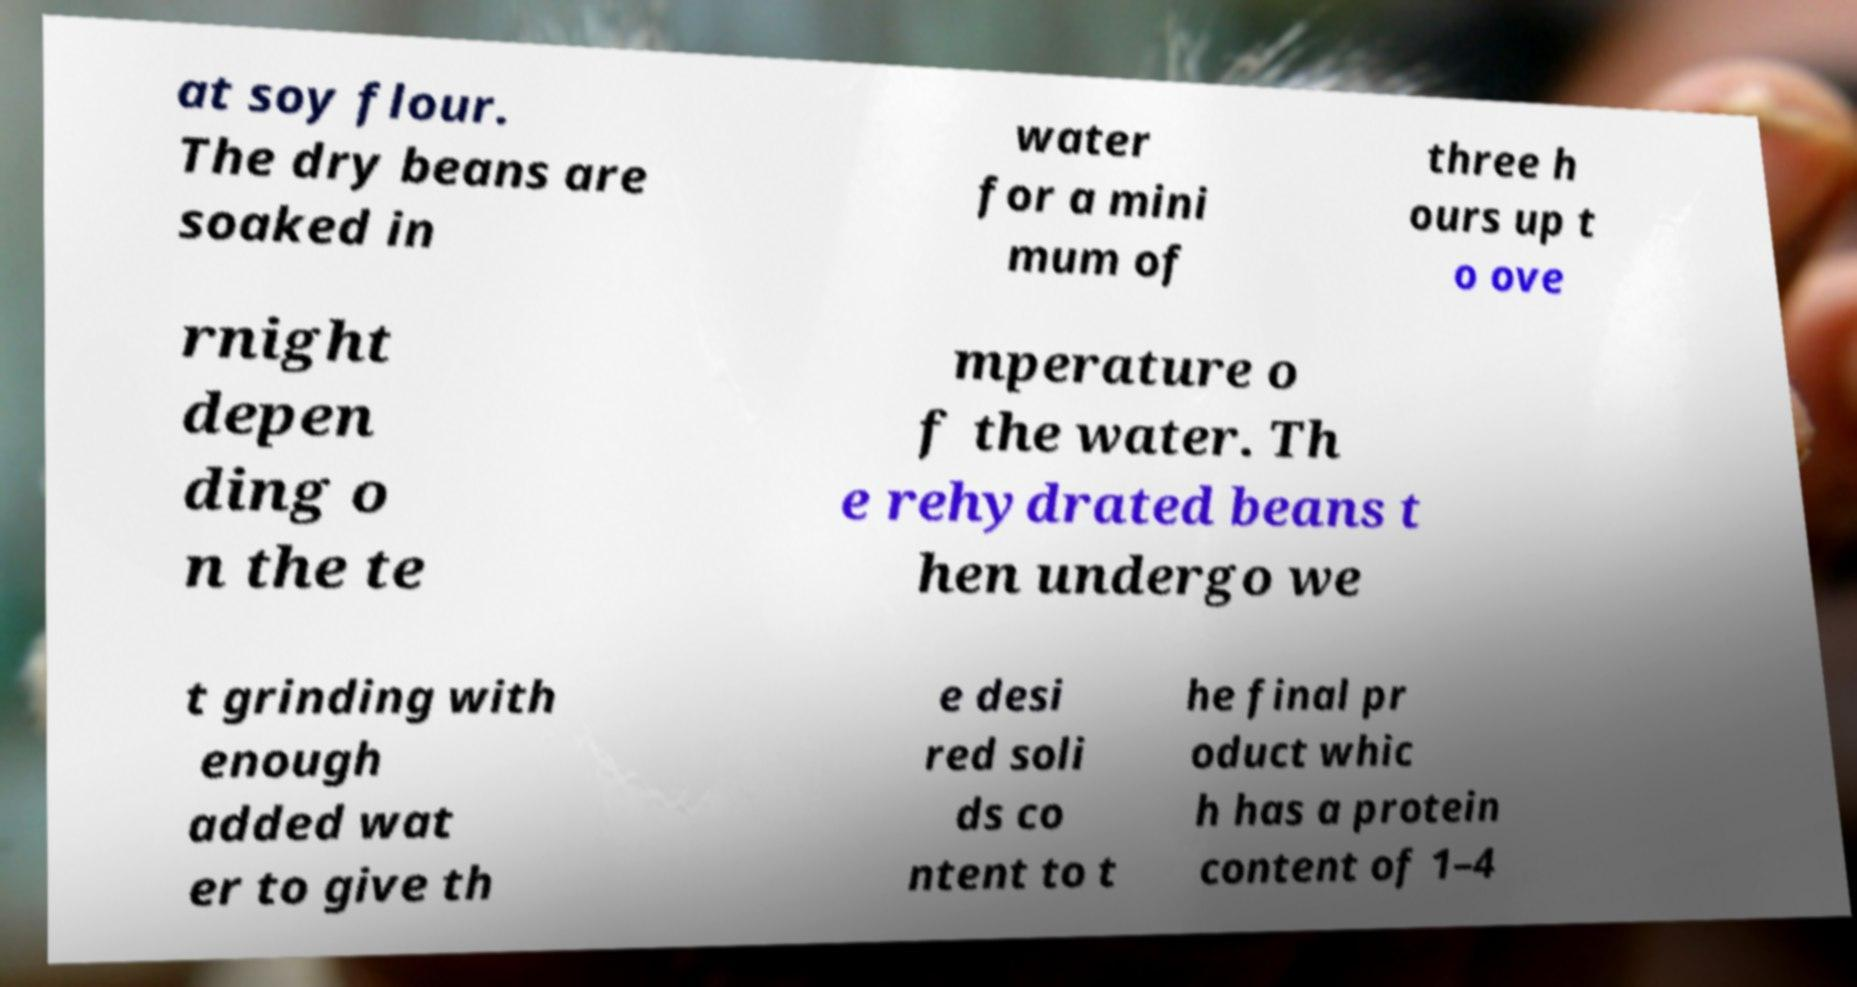For documentation purposes, I need the text within this image transcribed. Could you provide that? at soy flour. The dry beans are soaked in water for a mini mum of three h ours up t o ove rnight depen ding o n the te mperature o f the water. Th e rehydrated beans t hen undergo we t grinding with enough added wat er to give th e desi red soli ds co ntent to t he final pr oduct whic h has a protein content of 1–4 